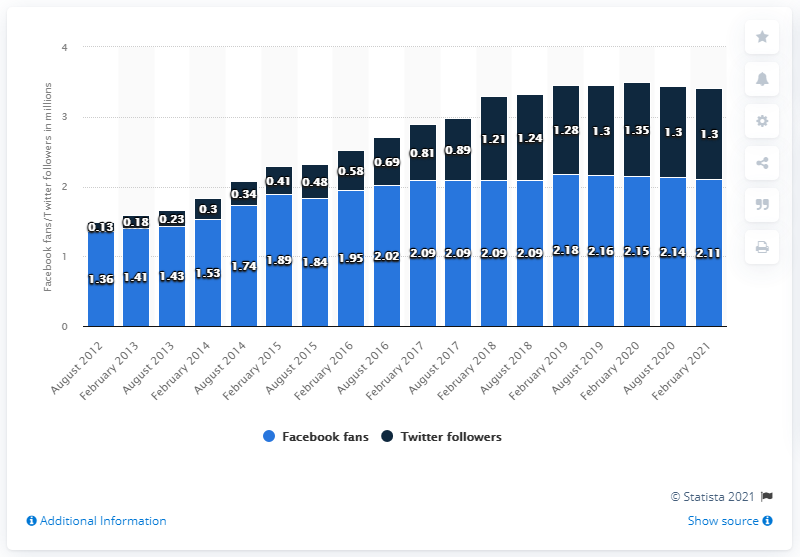Indicate a few pertinent items in this graphic. In February 2021, the Minnesota Vikings football team had approximately 2.11 million Facebook followers. 